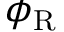Convert formula to latex. <formula><loc_0><loc_0><loc_500><loc_500>\phi _ { R }</formula> 